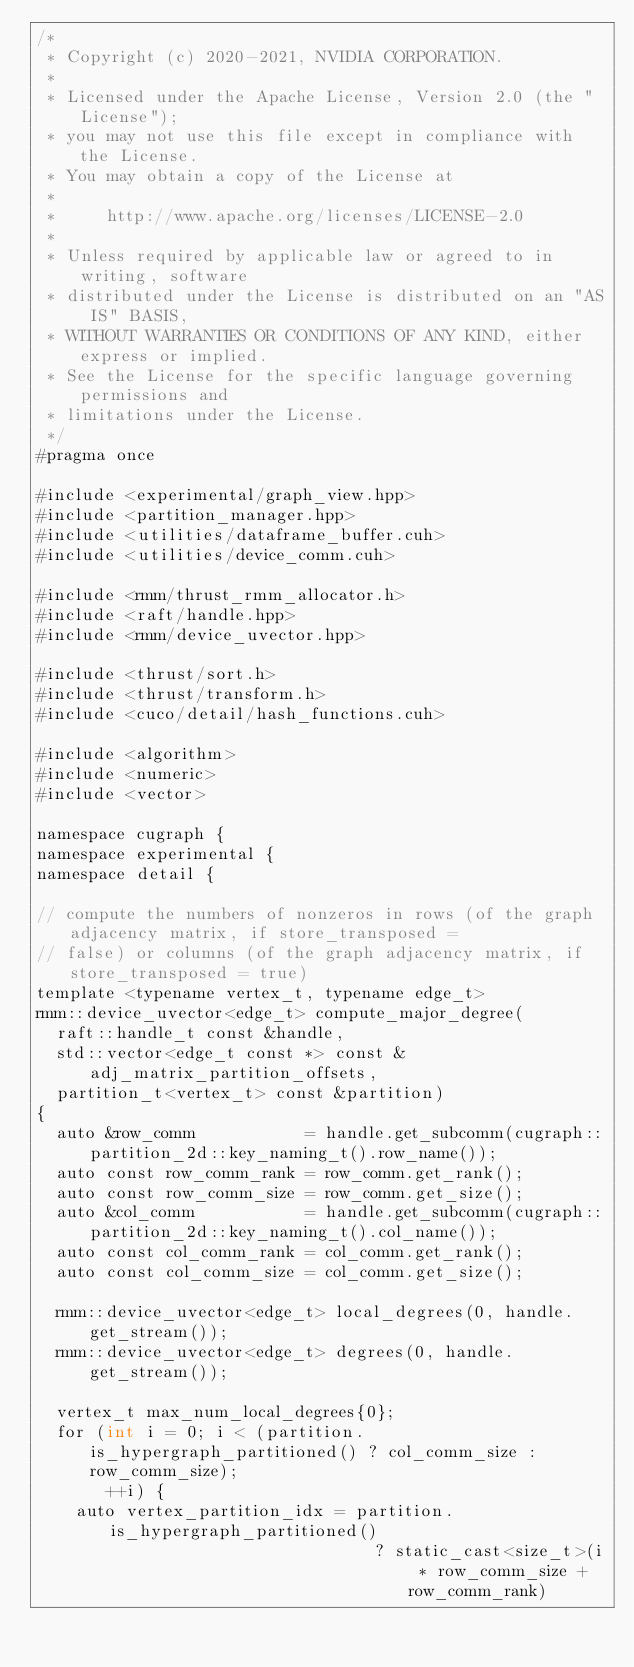<code> <loc_0><loc_0><loc_500><loc_500><_Cuda_>/*
 * Copyright (c) 2020-2021, NVIDIA CORPORATION.
 *
 * Licensed under the Apache License, Version 2.0 (the "License");
 * you may not use this file except in compliance with the License.
 * You may obtain a copy of the License at
 *
 *     http://www.apache.org/licenses/LICENSE-2.0
 *
 * Unless required by applicable law or agreed to in writing, software
 * distributed under the License is distributed on an "AS IS" BASIS,
 * WITHOUT WARRANTIES OR CONDITIONS OF ANY KIND, either express or implied.
 * See the License for the specific language governing permissions and
 * limitations under the License.
 */
#pragma once

#include <experimental/graph_view.hpp>
#include <partition_manager.hpp>
#include <utilities/dataframe_buffer.cuh>
#include <utilities/device_comm.cuh>

#include <rmm/thrust_rmm_allocator.h>
#include <raft/handle.hpp>
#include <rmm/device_uvector.hpp>

#include <thrust/sort.h>
#include <thrust/transform.h>
#include <cuco/detail/hash_functions.cuh>

#include <algorithm>
#include <numeric>
#include <vector>

namespace cugraph {
namespace experimental {
namespace detail {

// compute the numbers of nonzeros in rows (of the graph adjacency matrix, if store_transposed =
// false) or columns (of the graph adjacency matrix, if store_transposed = true)
template <typename vertex_t, typename edge_t>
rmm::device_uvector<edge_t> compute_major_degree(
  raft::handle_t const &handle,
  std::vector<edge_t const *> const &adj_matrix_partition_offsets,
  partition_t<vertex_t> const &partition)
{
  auto &row_comm           = handle.get_subcomm(cugraph::partition_2d::key_naming_t().row_name());
  auto const row_comm_rank = row_comm.get_rank();
  auto const row_comm_size = row_comm.get_size();
  auto &col_comm           = handle.get_subcomm(cugraph::partition_2d::key_naming_t().col_name());
  auto const col_comm_rank = col_comm.get_rank();
  auto const col_comm_size = col_comm.get_size();

  rmm::device_uvector<edge_t> local_degrees(0, handle.get_stream());
  rmm::device_uvector<edge_t> degrees(0, handle.get_stream());

  vertex_t max_num_local_degrees{0};
  for (int i = 0; i < (partition.is_hypergraph_partitioned() ? col_comm_size : row_comm_size);
       ++i) {
    auto vertex_partition_idx = partition.is_hypergraph_partitioned()
                                  ? static_cast<size_t>(i * row_comm_size + row_comm_rank)</code> 